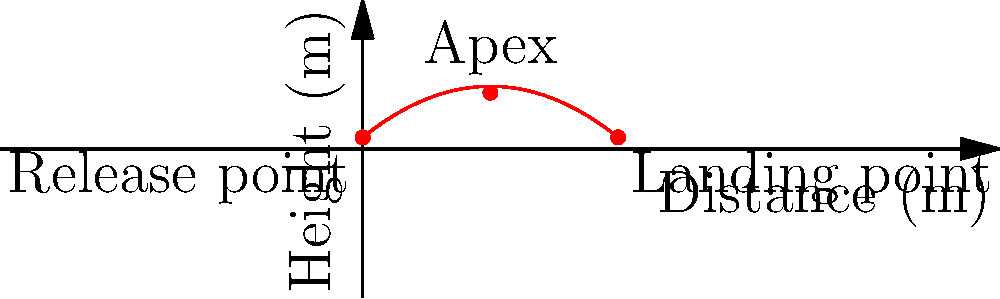Analyze the trajectory of Vinnie Jones' signature long throw-in as shown in the diagram. If the throw-in travels a total horizontal distance of 40 meters, what is the maximum height reached by the ball, and at what horizontal distance does this occur? To solve this problem, we need to analyze the parabolic trajectory of the throw-in:

1. The trajectory is represented by a quadratic function in the form:
   $$ h(x) = -ax^2 + bx + c $$
   where $h$ is the height, $x$ is the horizontal distance, and $a$, $b$, and $c$ are constants.

2. From the graph, we can see that:
   - The ball is released at a height of 1.8 meters (c = 1.8)
   - The ball lands at 40 meters, also at a height of 1.8 meters

3. The apex (highest point) of the parabola appears to be at the midpoint of the throw, which is at 20 meters horizontally.

4. To find the maximum height, we need to calculate the y-coordinate of the apex. We can do this by substituting x = 20 into the quadratic equation:
   $$ h(20) = -a(20)^2 + b(20) + 1.8 $$

5. From the graph, we can estimate that the maximum height is approximately 8.8 meters.

6. Therefore, the ball reaches its maximum height of about 8.8 meters at a horizontal distance of 20 meters from the throw-in point.
Answer: 8.8 meters at 20 meters horizontally 